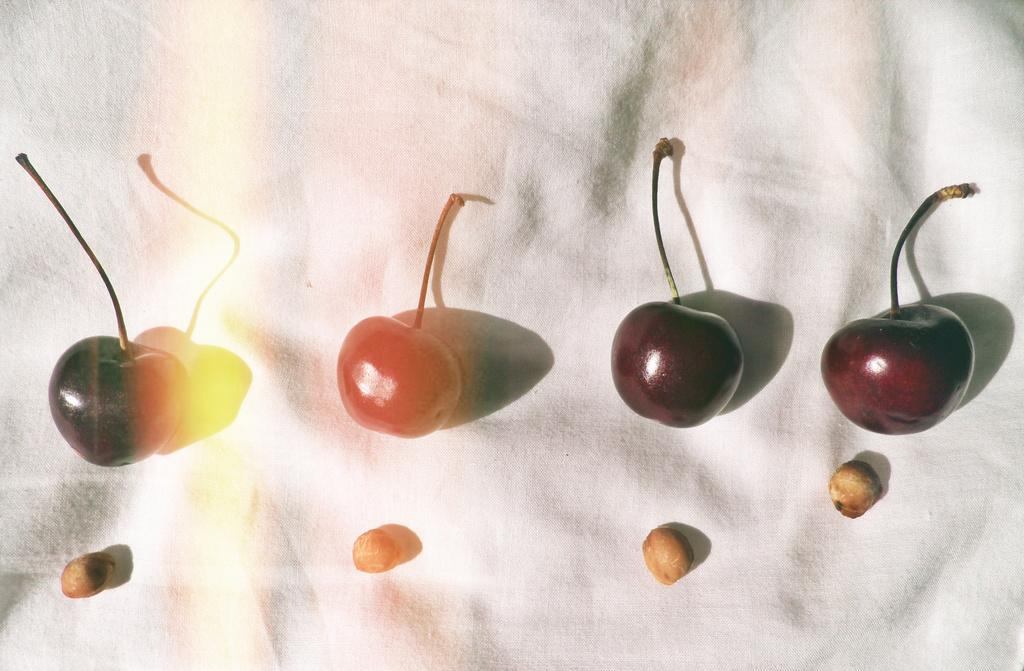What is the main subject of the image? The main subject of the image is fruits. Where are the fruits located in the image? The fruits are in the center of the image. What else can be seen in the background of the image? There is a cloth in the background of the image. How does the image show an increase in lumber production? The image does not show any lumber production or an increase in it; it features fruits in the center and a cloth in the background. 